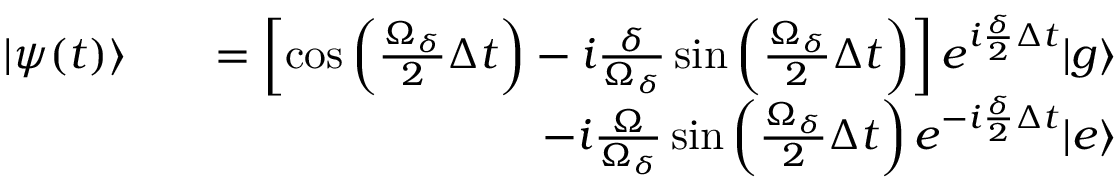<formula> <loc_0><loc_0><loc_500><loc_500>\begin{array} { r l r } { | \psi ( t ) \rangle } & { = \left [ \cos \left ( \frac { \Omega _ { \delta } } { 2 } \Delta t \right ) - i \frac { \delta } { \Omega _ { \delta } } \sin \left ( \frac { \Omega _ { \delta } } { 2 } \Delta t \right ) \right ] e ^ { i \frac { \delta } { 2 } \Delta t } | g \rangle } \\ & { - i \frac { \Omega } { \Omega _ { \delta } } \sin \left ( \frac { \Omega _ { \delta } } { 2 } \Delta t \right ) e ^ { - i \frac { \delta } { 2 } \Delta t } | e \rangle } \end{array}</formula> 